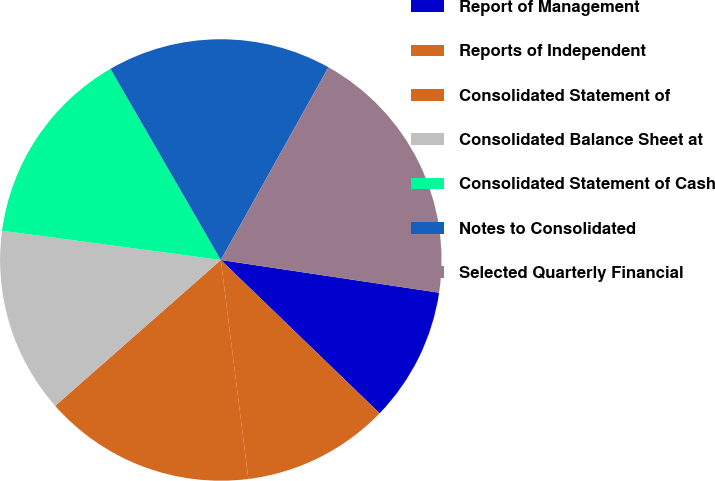Convert chart. <chart><loc_0><loc_0><loc_500><loc_500><pie_chart><fcel>Report of Management<fcel>Reports of Independent<fcel>Consolidated Statement of<fcel>Consolidated Balance Sheet at<fcel>Consolidated Statement of Cash<fcel>Notes to Consolidated<fcel>Selected Quarterly Financial<nl><fcel>9.85%<fcel>10.79%<fcel>15.5%<fcel>13.61%<fcel>14.55%<fcel>16.44%<fcel>19.26%<nl></chart> 